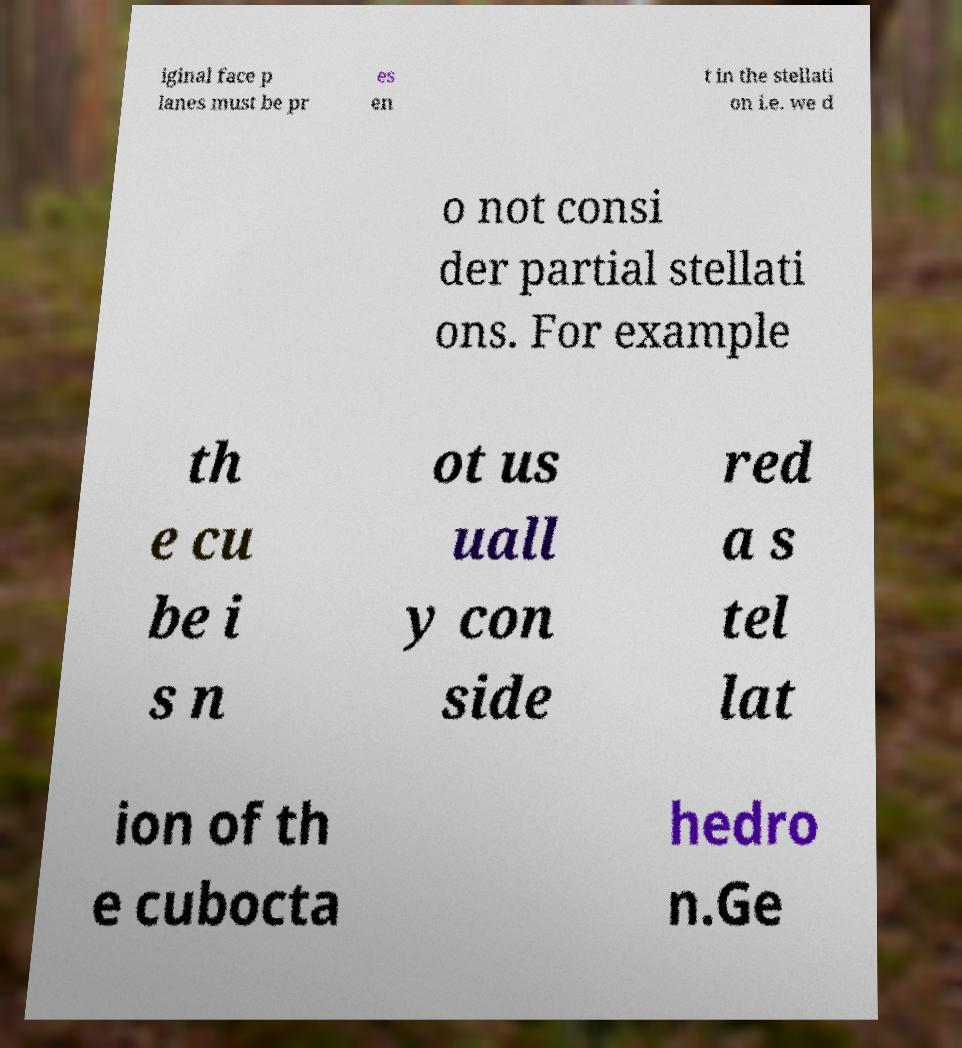Please identify and transcribe the text found in this image. iginal face p lanes must be pr es en t in the stellati on i.e. we d o not consi der partial stellati ons. For example th e cu be i s n ot us uall y con side red a s tel lat ion of th e cubocta hedro n.Ge 